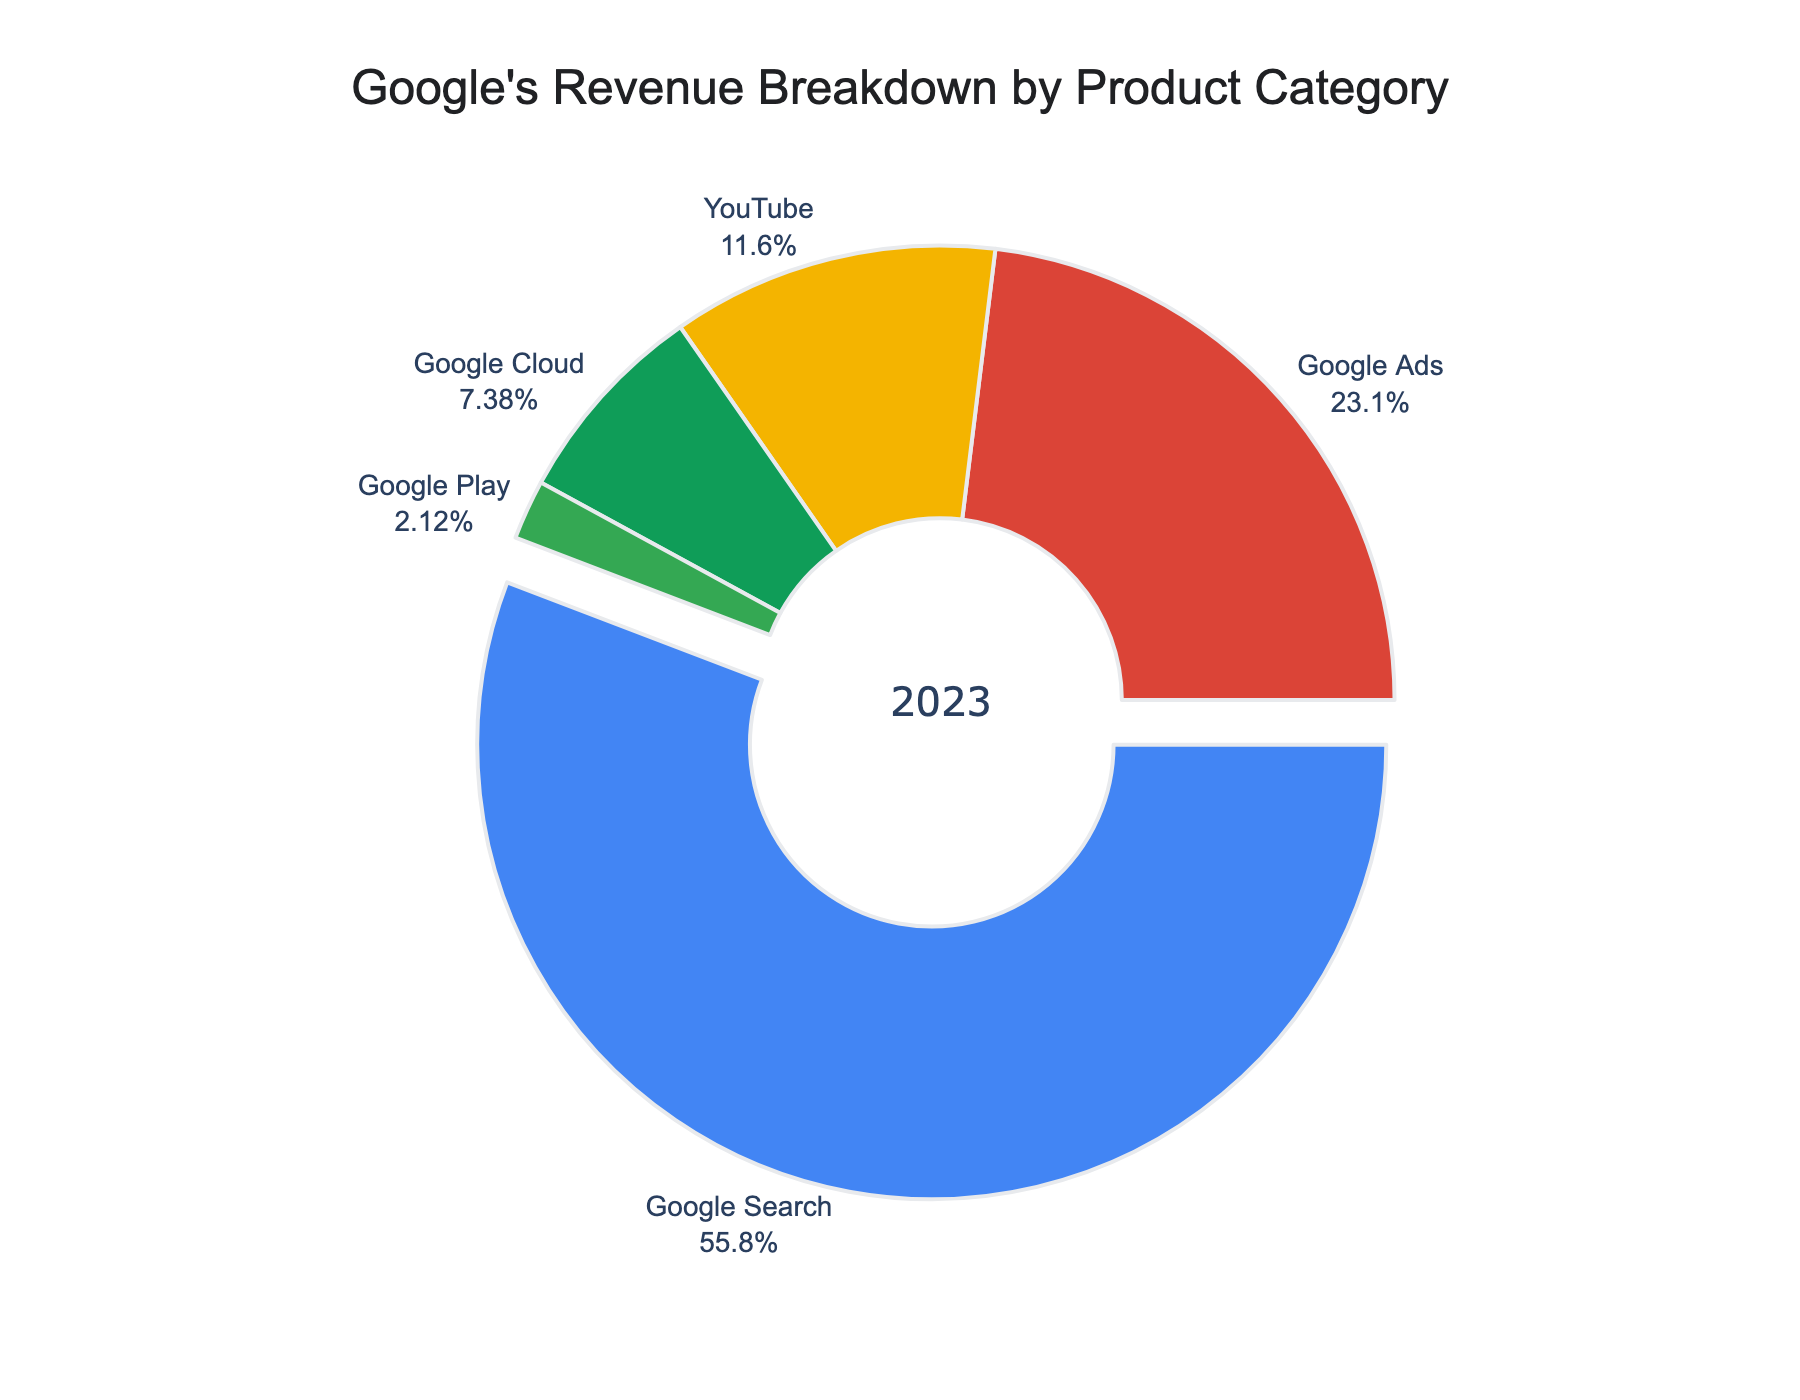What percentage of Google's revenue comes from Google Play compared to Google Cloud? Based on the pie chart, Google Play contributes 2.1% to the revenue, while Google Cloud contributes 7.3%. To find the difference, subtract the smaller percentage (2.1%) from the larger percentage (7.3%). Therefore, 7.3% - 2.1% = 5.2%.
Answer: 5.2% What is the total percentage revenue for YouTube and Google Cloud combined? Looking at the breakdown, YouTube contributes 11.5% and Google Cloud contributes 7.3%. Adding these together gives 11.5% + 7.3% = 18.8%.
Answer: 18.8% Which product category has the largest share of revenue, and what is its percentage? According to the figure, Google Search has the largest share of revenue. Its percentage is explicitly labeled as 55.2%.
Answer: Google Search, 55.2% Is the combined revenue from Google Ads and Google Play greater than the revenue from YouTube? Google Ads contributes 22.8% and Google Play contributes 2.1%, so their combined revenue is 22.8% + 2.1% = 24.9%. YouTube contributes 11.5%. Since 24.9% is greater than 11.5%, the combined revenue from Google Ads and Google Play is greater than that from YouTube.
Answer: Yes What fraction of Google's revenue comes from Google Search and Google Ads together? Google Search contributes 55.2% and Google Ads contributes 22.8%. Adding these gives 55.2% + 22.8% = 78%. To express 78% as a fraction, it is 78/100 = 39/50.
Answer: 39/50 What is the difference in revenue percentage between the highest and the lowest revenue-generating categories? Google Search is the highest at 55.2%, and Google Play is the lowest at 2.1%. The difference is 55.2% - 2.1% = 53.1%.
Answer: 53.1% How much more revenue does YouTube generate compared to Google Play? YouTube generates 11.5% of the revenue, and Google Play generates 2.1%. The difference is 11.5% - 2.1% = 9.4%.
Answer: 9.4% What is the second largest revenue-generating category? The pie chart shows that after Google Search (55.2%), Google Ads is the second largest with 22.8%.
Answer: Google Ads If we combine Google Cloud and Google Play, what percentage of revenue does this new category represent? Google Cloud contributes 7.3% and Google Play contributes 2.1%. Their combined percentage is 7.3% + 2.1% = 9.4%.
Answer: 9.4% Which category has nearly half the revenue contribution of Google Search? Google Search contributes 55.2%. Google Ads contributes 22.8%, which is nearly half of 55.2% (27.6% would be exactly half).
Answer: Google Ads 